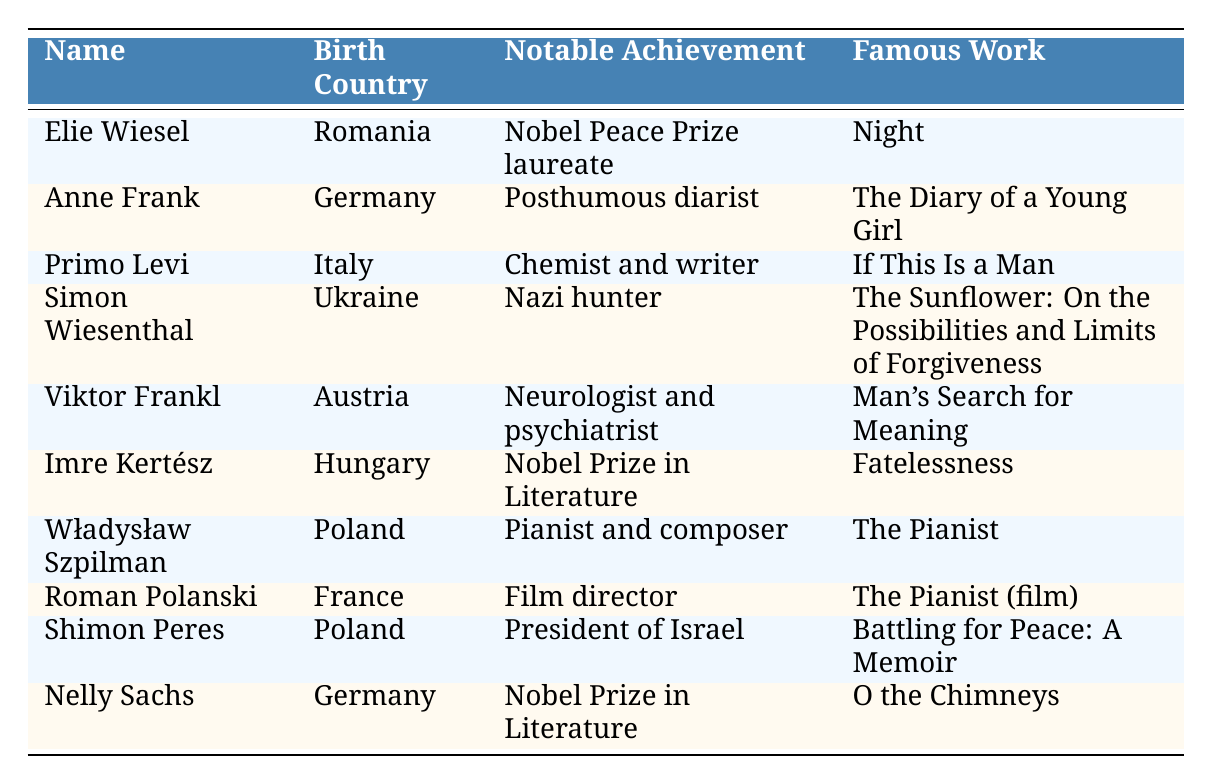What is the birth country of Elie Wiesel? The table states that Elie Wiesel was born in Romania. There is a direct correlation between the name and the birth country provided in the respective row.
Answer: Romania Which notable achievement is associated with Viktor Frankl? According to the table, Viktor Frankl is noted as a neurologist and psychiatrist, which is mentioned in the column for 'Notable Achievement'.
Answer: Neurologist and psychiatrist How many Holocaust survivors listed were born in Germany? The table lists two individuals associated with Germany: Anne Frank and Nelly Sachs. Counting these entries gives the total.
Answer: 2 What famous work did Primo Levi author? The table specifies that Primo Levi's noted famous work is "If This Is a Man," which is recorded in the corresponding column.
Answer: If This Is a Man Is Simon Wiesenthal recognized as a Nobel Prize laureate? By examining the table, it shows Simon Wiesenthal's notable achievement as a Nazi hunter. He is not recorded as a recipient of the Nobel Prize, which means the answer is no.
Answer: No From which two countries were the notable survivors who won Nobel Prizes in Literature? The table includes two individuals with this notable achievement: Imre Kertész from Hungary and Nelly Sachs from Germany. Both names can be identified along with their birth countries.
Answer: Hungary and Germany Which individual in the table has the longest achieved fame? Analyzing the entries, Elie Wiesel is both a Nobel Peace Prize laureate and associated with an influential work "Night," which remains impactful over decades, making him significant in this context.
Answer: Elie Wiesel How many individuals listed were born in Poland? The table features two individuals from Poland: Władysław Szpilman and Shimon Peres. Counting these entries confirms the total.
Answer: 2 Did any listed Holocaust survivors also achieve recognition as film directors? The table identifies Roman Polanski as a film director. By checking the column for notable achievements, this confirms the presence of a film director in the list.
Answer: Yes What is the relationship between Anne Frank and Nelly Sachs regarding their notable achievements? The table indicates that both Anne Frank and Nelly Sachs have notable achievements linked to literature, but only Anne Frank is identified as a posthumous diarist, while Nelly Sachs was a Nobel Prize laureate in that field. This indicates they both relate to literature but in different capacities.
Answer: Related to literature, but different accomplishments 